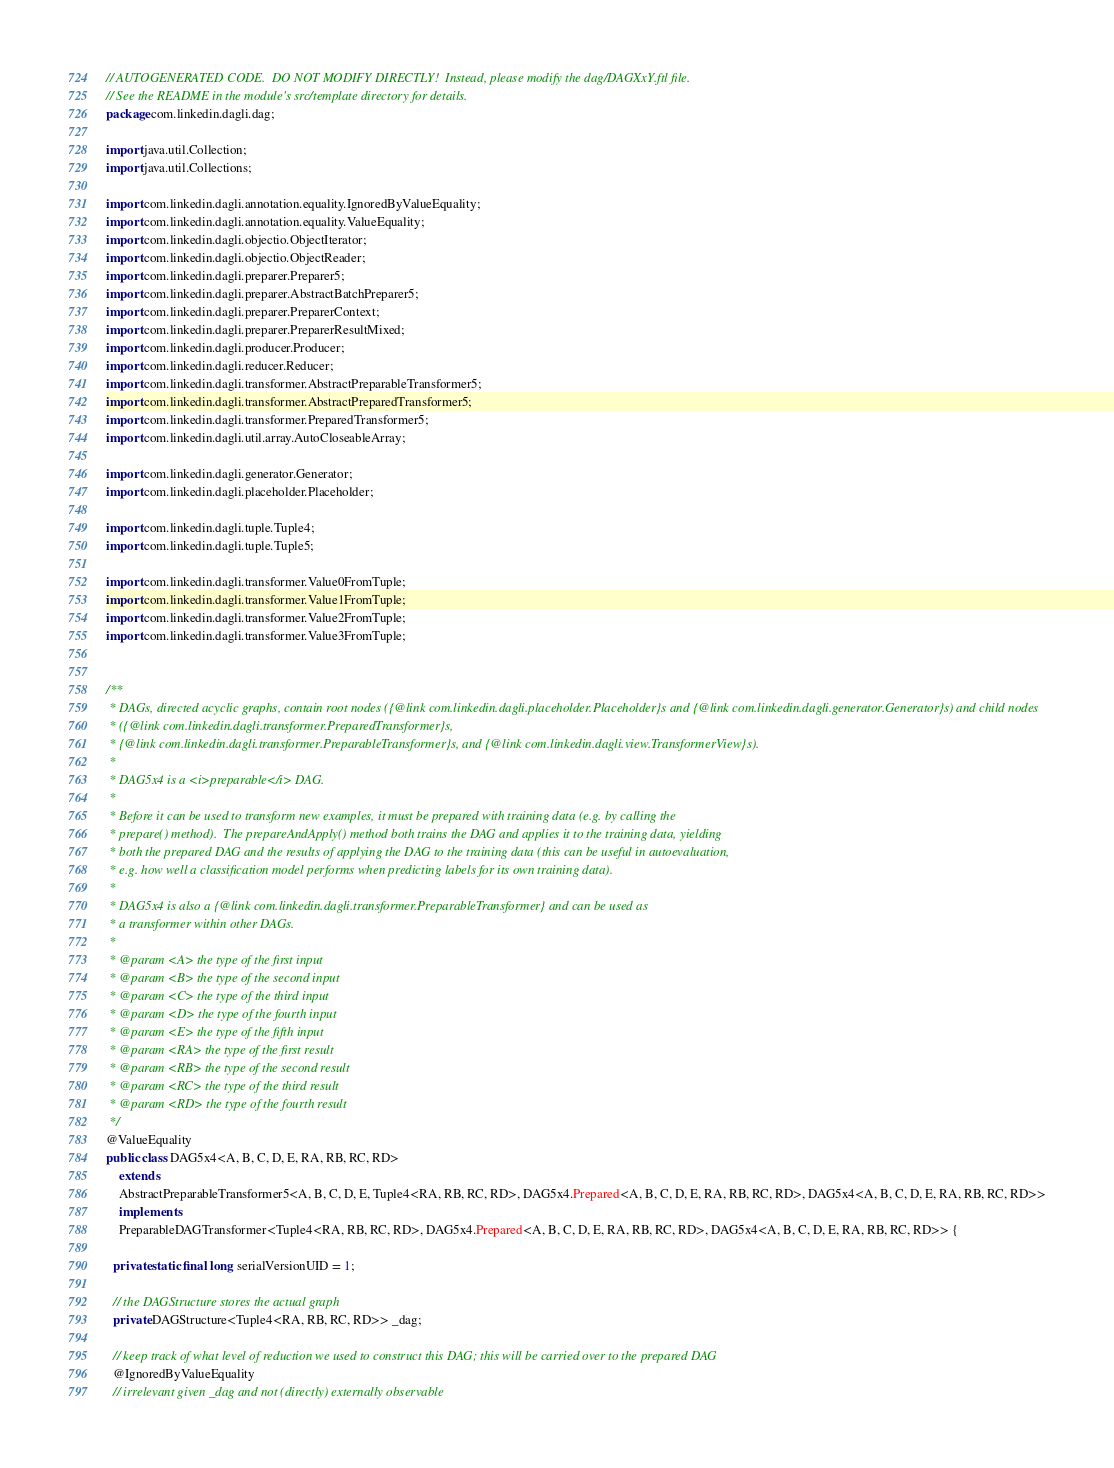Convert code to text. <code><loc_0><loc_0><loc_500><loc_500><_Java_>// AUTOGENERATED CODE.  DO NOT MODIFY DIRECTLY!  Instead, please modify the dag/DAGXxY.ftl file.
// See the README in the module's src/template directory for details.
package com.linkedin.dagli.dag;

import java.util.Collection;
import java.util.Collections;

import com.linkedin.dagli.annotation.equality.IgnoredByValueEquality;
import com.linkedin.dagli.annotation.equality.ValueEquality;
import com.linkedin.dagli.objectio.ObjectIterator;
import com.linkedin.dagli.objectio.ObjectReader;
import com.linkedin.dagli.preparer.Preparer5;
import com.linkedin.dagli.preparer.AbstractBatchPreparer5;
import com.linkedin.dagli.preparer.PreparerContext;
import com.linkedin.dagli.preparer.PreparerResultMixed;
import com.linkedin.dagli.producer.Producer;
import com.linkedin.dagli.reducer.Reducer;
import com.linkedin.dagli.transformer.AbstractPreparableTransformer5;
import com.linkedin.dagli.transformer.AbstractPreparedTransformer5;
import com.linkedin.dagli.transformer.PreparedTransformer5;
import com.linkedin.dagli.util.array.AutoCloseableArray;

import com.linkedin.dagli.generator.Generator;
import com.linkedin.dagli.placeholder.Placeholder;

import com.linkedin.dagli.tuple.Tuple4;
import com.linkedin.dagli.tuple.Tuple5;

import com.linkedin.dagli.transformer.Value0FromTuple;
import com.linkedin.dagli.transformer.Value1FromTuple;
import com.linkedin.dagli.transformer.Value2FromTuple;
import com.linkedin.dagli.transformer.Value3FromTuple;


/**
 * DAGs, directed acyclic graphs, contain root nodes ({@link com.linkedin.dagli.placeholder.Placeholder}s and {@link com.linkedin.dagli.generator.Generator}s) and child nodes
 * ({@link com.linkedin.dagli.transformer.PreparedTransformer}s,
 * {@link com.linkedin.dagli.transformer.PreparableTransformer}s, and {@link com.linkedin.dagli.view.TransformerView}s).
 *
 * DAG5x4 is a <i>preparable</i> DAG.
 *
 * Before it can be used to transform new examples, it must be prepared with training data (e.g. by calling the
 * prepare() method).  The prepareAndApply() method both trains the DAG and applies it to the training data, yielding
 * both the prepared DAG and the results of applying the DAG to the training data (this can be useful in autoevaluation,
 * e.g. how well a classification model performs when predicting labels for its own training data).
 *
 * DAG5x4 is also a {@link com.linkedin.dagli.transformer.PreparableTransformer} and can be used as
 * a transformer within other DAGs.
 *
 * @param <A> the type of the first input
 * @param <B> the type of the second input
 * @param <C> the type of the third input
 * @param <D> the type of the fourth input
 * @param <E> the type of the fifth input
 * @param <RA> the type of the first result
 * @param <RB> the type of the second result
 * @param <RC> the type of the third result
 * @param <RD> the type of the fourth result
 */
@ValueEquality
public class DAG5x4<A, B, C, D, E, RA, RB, RC, RD>
    extends
    AbstractPreparableTransformer5<A, B, C, D, E, Tuple4<RA, RB, RC, RD>, DAG5x4.Prepared<A, B, C, D, E, RA, RB, RC, RD>, DAG5x4<A, B, C, D, E, RA, RB, RC, RD>>
    implements
    PreparableDAGTransformer<Tuple4<RA, RB, RC, RD>, DAG5x4.Prepared<A, B, C, D, E, RA, RB, RC, RD>, DAG5x4<A, B, C, D, E, RA, RB, RC, RD>> {

  private static final long serialVersionUID = 1;

  // the DAGStructure stores the actual graph
  private DAGStructure<Tuple4<RA, RB, RC, RD>> _dag;

  // keep track of what level of reduction we used to construct this DAG; this will be carried over to the prepared DAG
  @IgnoredByValueEquality
  // irrelevant given _dag and not (directly) externally observable</code> 